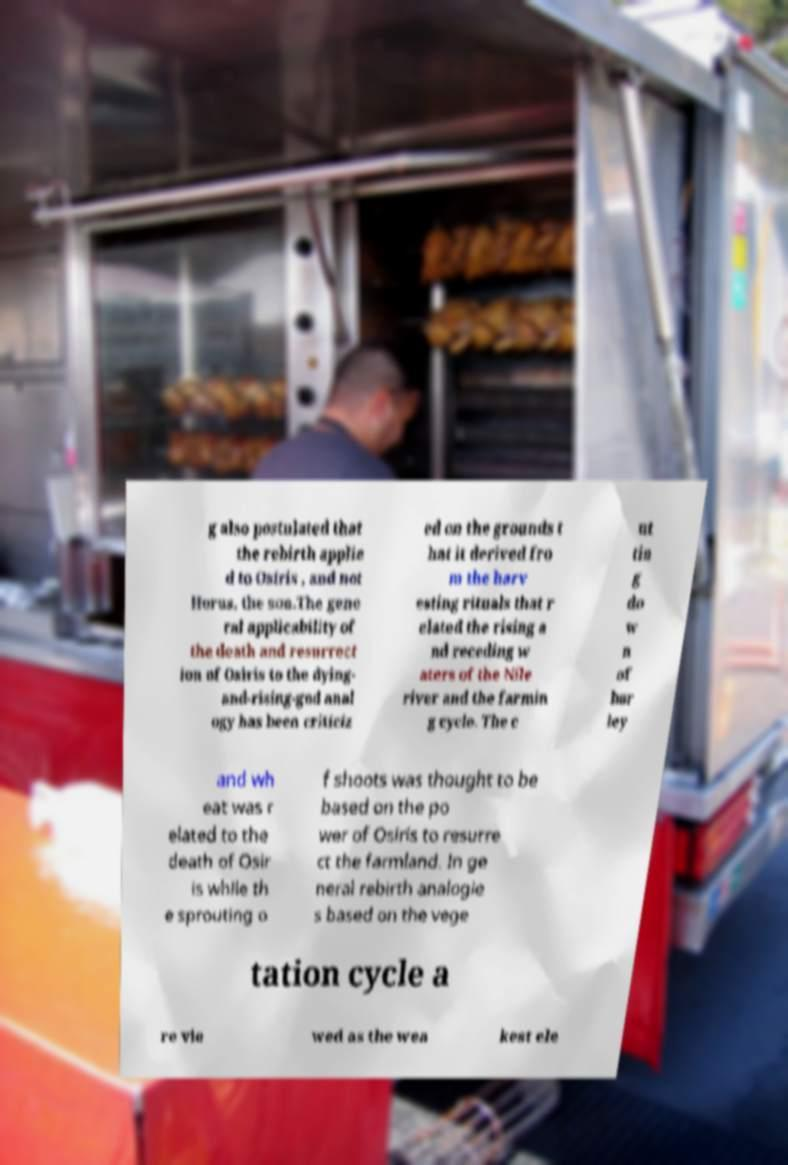For documentation purposes, I need the text within this image transcribed. Could you provide that? g also postulated that the rebirth applie d to Osiris , and not Horus, the son.The gene ral applicability of the death and resurrect ion of Osiris to the dying- and-rising-god anal ogy has been criticiz ed on the grounds t hat it derived fro m the harv esting rituals that r elated the rising a nd receding w aters of the Nile river and the farmin g cycle. The c ut tin g do w n of bar ley and wh eat was r elated to the death of Osir is while th e sprouting o f shoots was thought to be based on the po wer of Osiris to resurre ct the farmland. In ge neral rebirth analogie s based on the vege tation cycle a re vie wed as the wea kest ele 